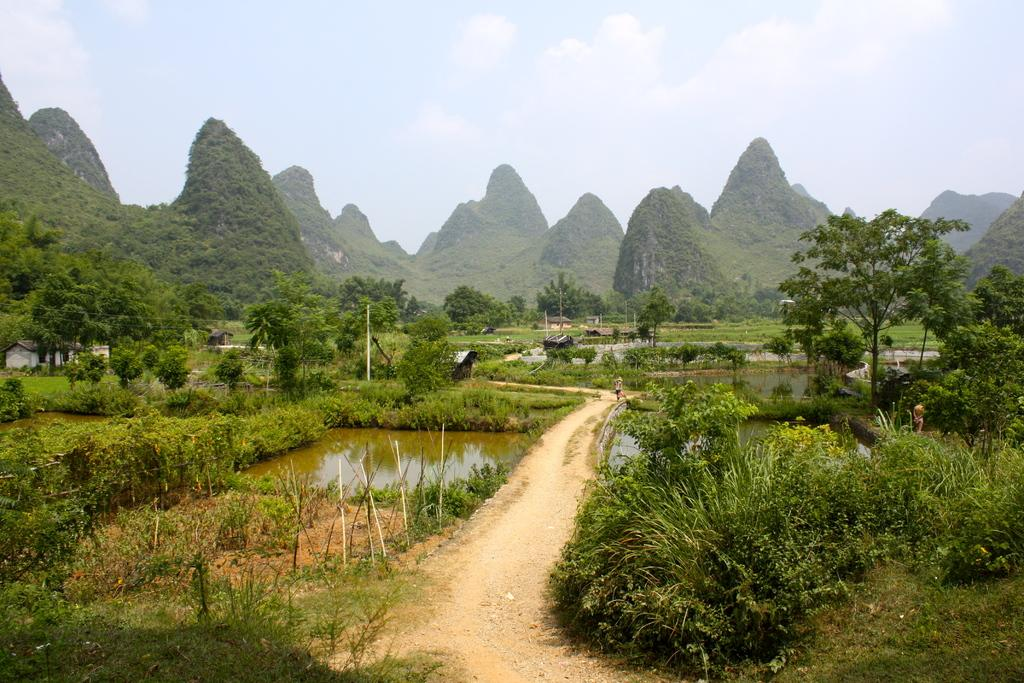What type of vegetation can be seen in the image? There are trees and plants in the image. What can be seen in the background of the image? There are hills visible in the background of the image. What is the condition of the sky in the image? The sky is visible at the top of the image. What type of ground cover is present in the image? There is grass in the image. What natural feature is visible in the image? There is water visible in the image. What type of structure is present in the image? There is a house in the image. How many boots are visible in the image? There are no boots present in the image. What type of account is being discussed in the image? There is no account being discussed in the image. 